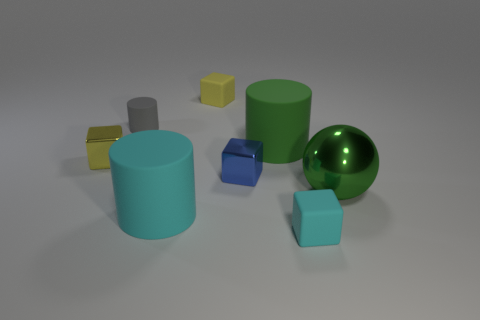Can you guess the material composition of these objects? Based on the visual attributes, the shiny sphere suggests a reflective metal, whereas the cylinders and cubes, having matte surfaces, might be made of plastic or a similar non-metallic, non-reflective material. How does lighting affect the perception of these objects? The lighting in the scene creates subtle shadows and highlights which give depth and dimension to the objects. The metallic sphere, in particular, reflects the light strongly, emphasizing its smooth curvature, whereas the more diffuse reflection on the other shapes gives a soft appearance. 